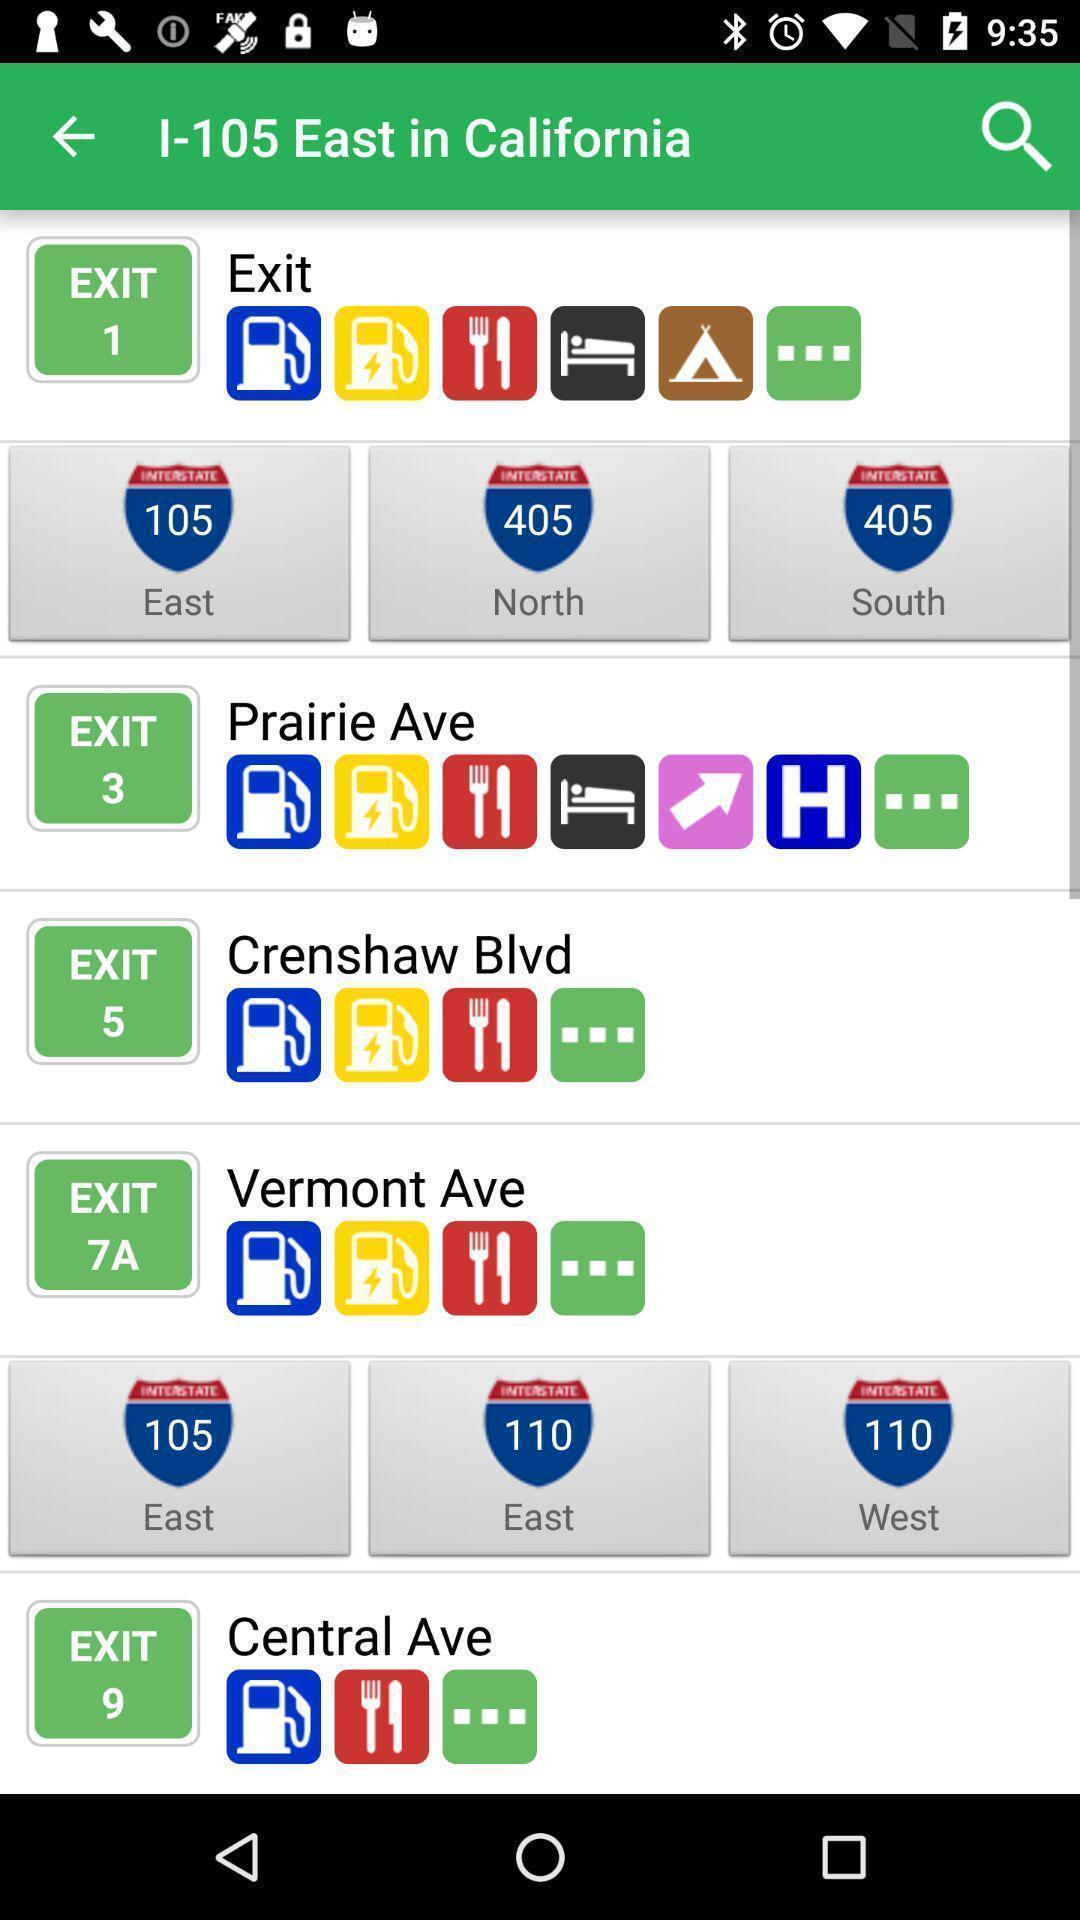What can you discern from this picture? Screen shows multiple options. 